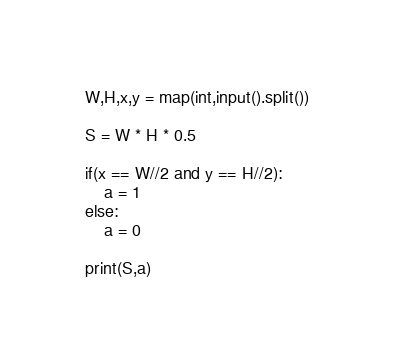<code> <loc_0><loc_0><loc_500><loc_500><_Python_>W,H,x,y = map(int,input().split())

S = W * H * 0.5

if(x == W//2 and y == H//2):
    a = 1
else:
    a = 0

print(S,a)</code> 